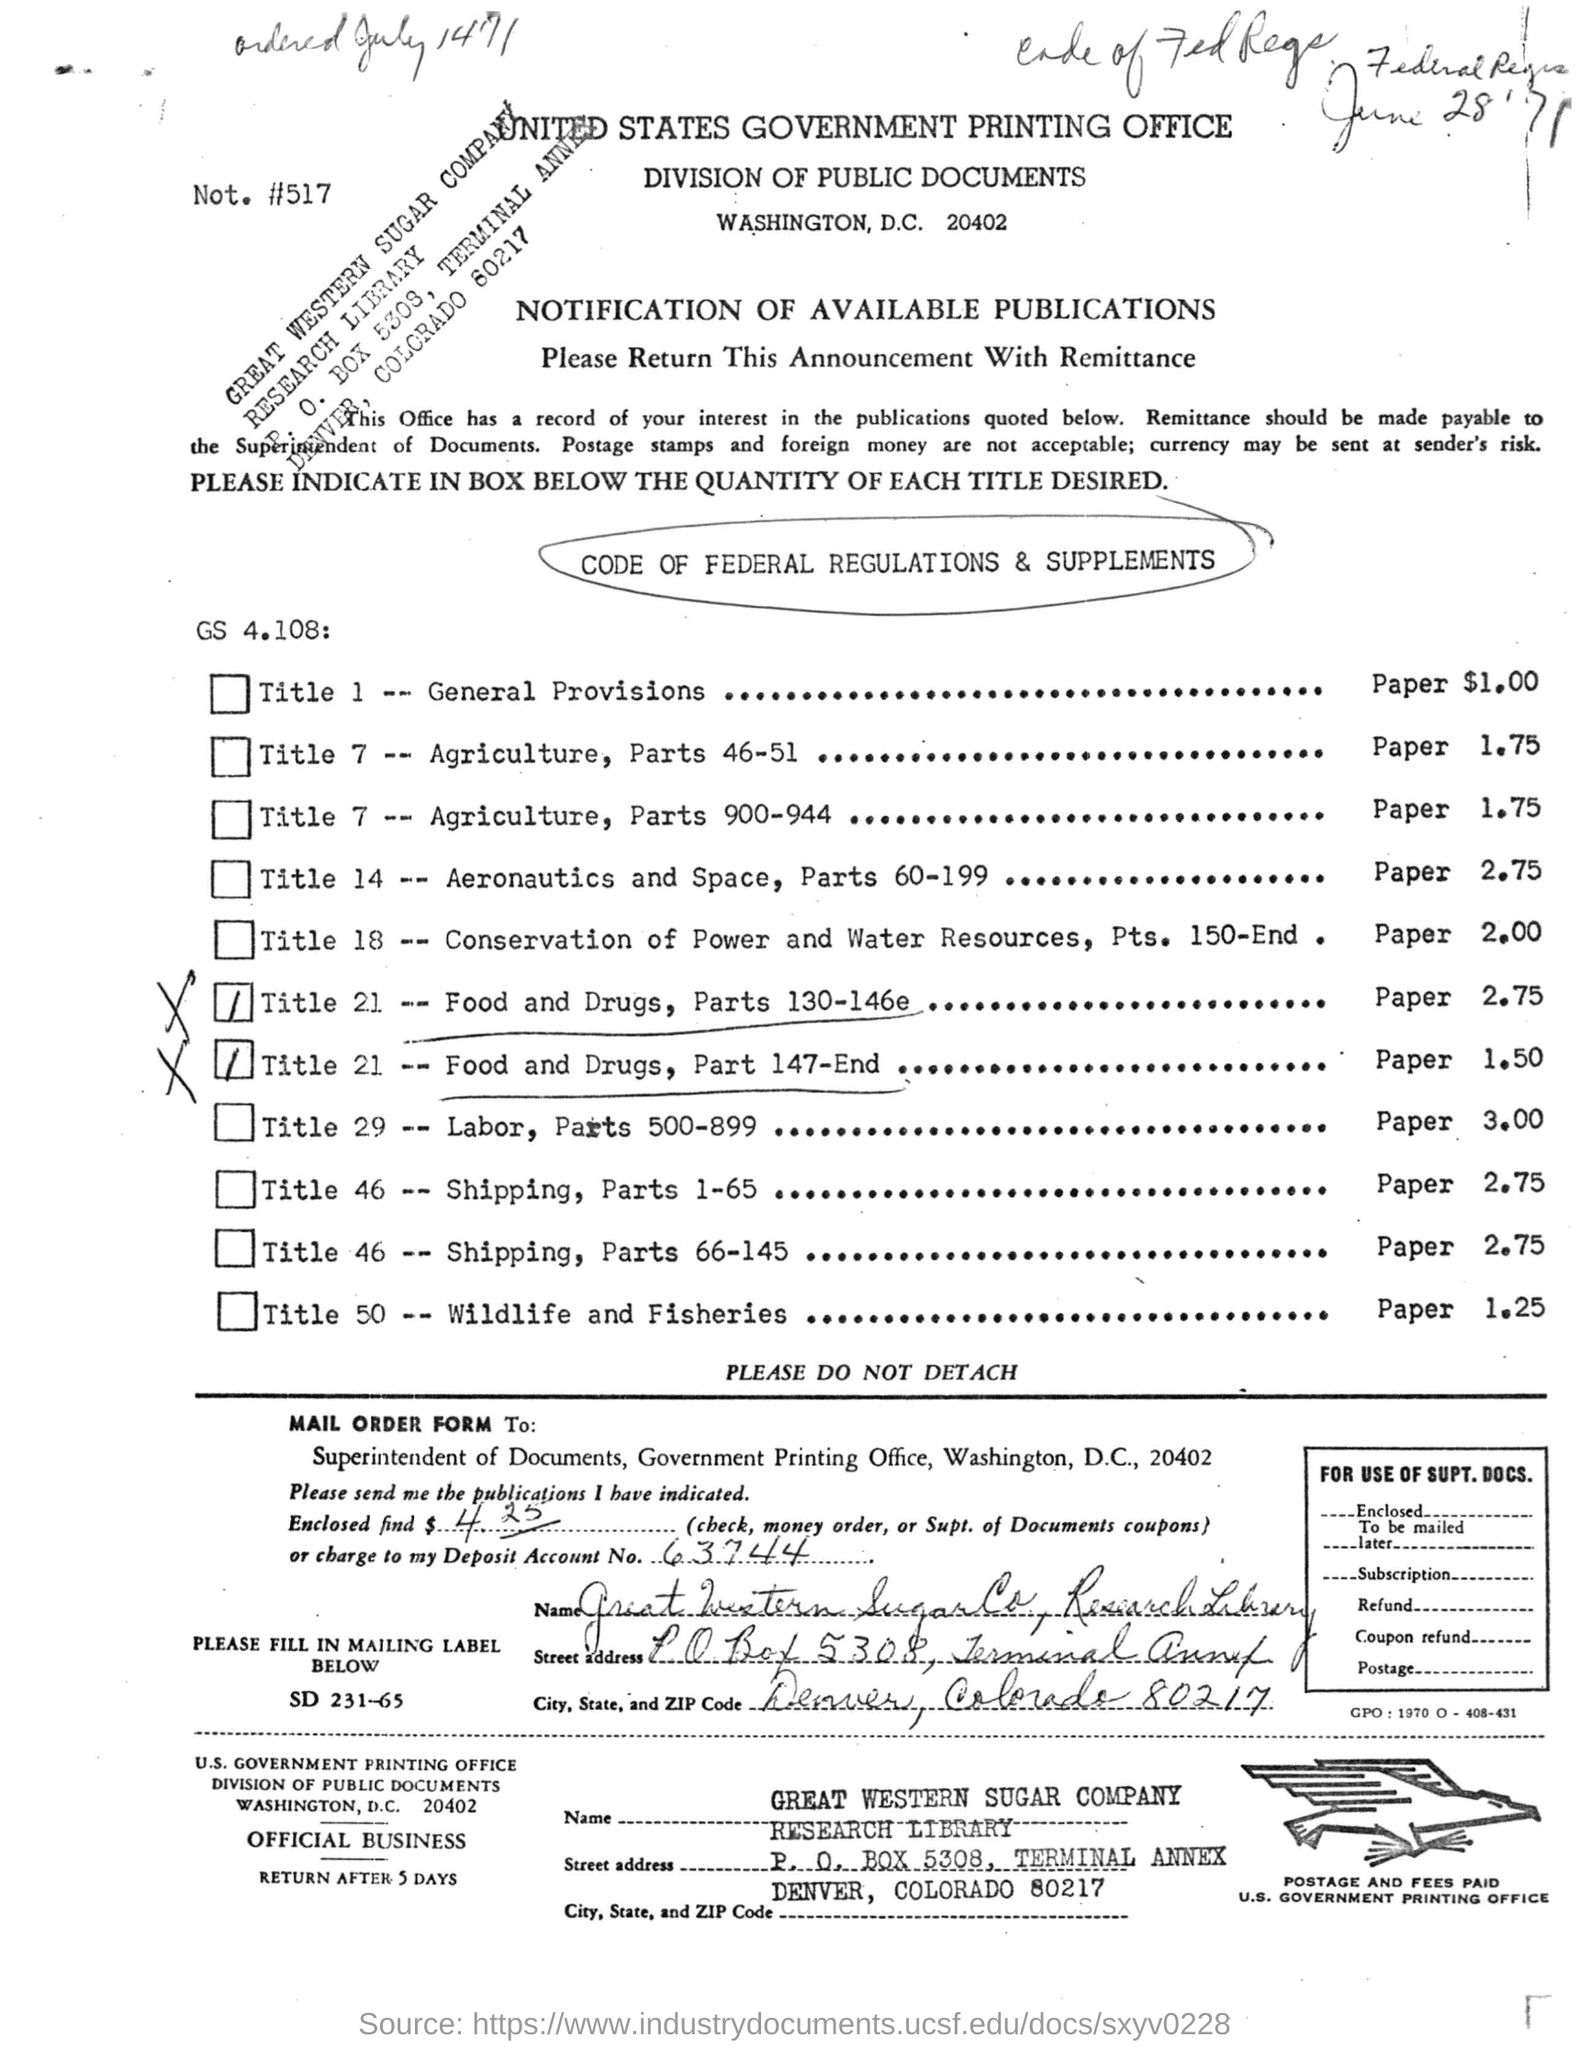Which is the printing office mentioned in the letter head?
Provide a short and direct response. UNITED STATES GOVERNMENT PRINTING OFFICE. To whom is the MAIL ORDER FORM TO?
Ensure brevity in your answer.  Superintendent of Documents. What is the Deposit Account No mentioned?
Your response must be concise. 63744. Which state is mentioned in the mailing label?
Offer a terse response. Colorado. What is the ZipCode of the mailing address?
Offer a very short reply. 80217. After how many days the MAIL ORDER FORM will return?
Offer a terse response. 5. 